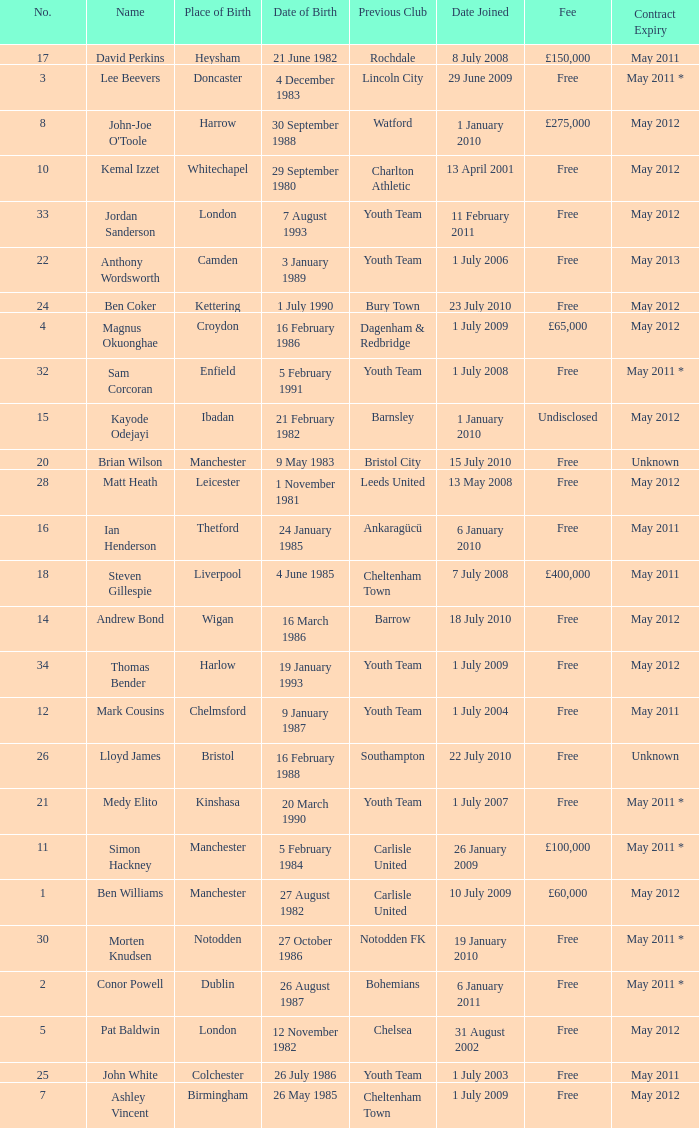For the ben williams name what was the previous club Carlisle United. 